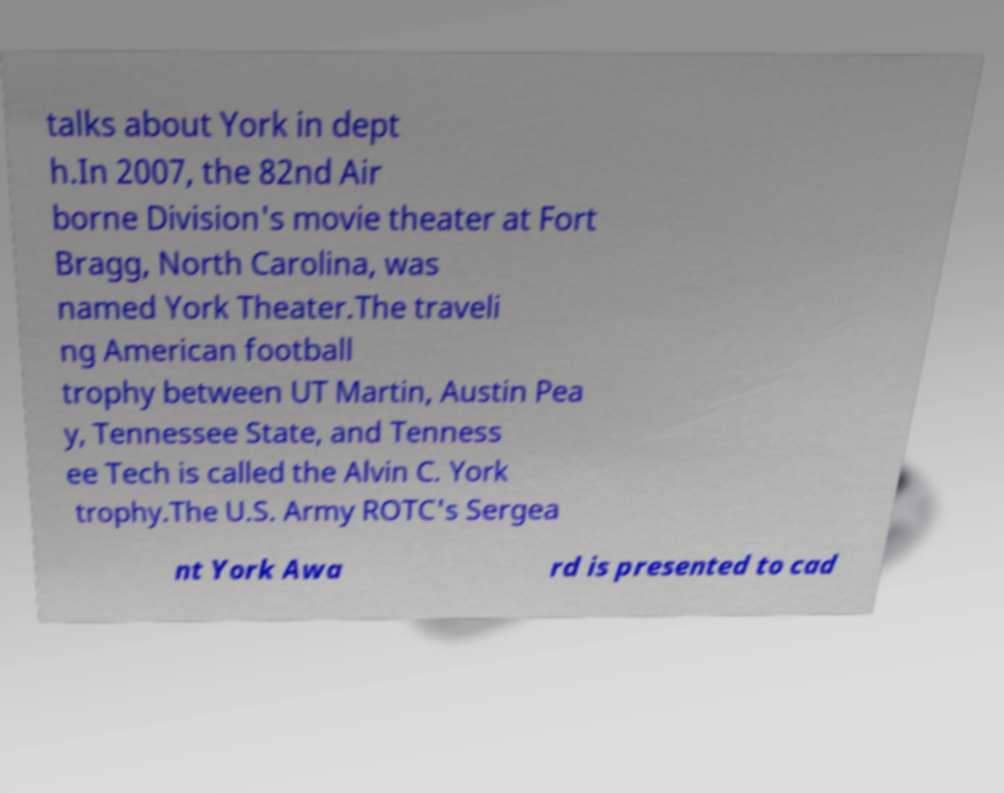Please read and relay the text visible in this image. What does it say? talks about York in dept h.In 2007, the 82nd Air borne Division's movie theater at Fort Bragg, North Carolina, was named York Theater.The traveli ng American football trophy between UT Martin, Austin Pea y, Tennessee State, and Tenness ee Tech is called the Alvin C. York trophy.The U.S. Army ROTC's Sergea nt York Awa rd is presented to cad 